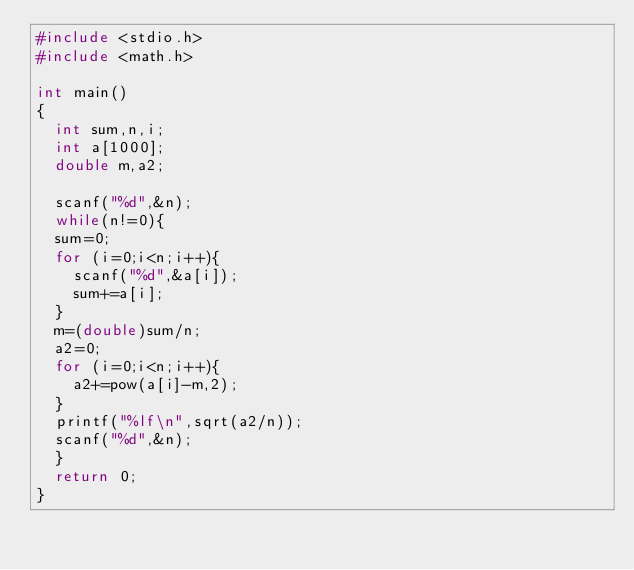Convert code to text. <code><loc_0><loc_0><loc_500><loc_500><_C_>#include <stdio.h>
#include <math.h>

int main()
{
  int sum,n,i;
  int a[1000];
  double m,a2;

  scanf("%d",&n);
  while(n!=0){
  sum=0;
  for (i=0;i<n;i++){
    scanf("%d",&a[i]);
    sum+=a[i];
  }
  m=(double)sum/n;
  a2=0;
  for (i=0;i<n;i++){
    a2+=pow(a[i]-m,2);
  }
  printf("%lf\n",sqrt(a2/n));
  scanf("%d",&n);
  }
  return 0;
}

</code> 